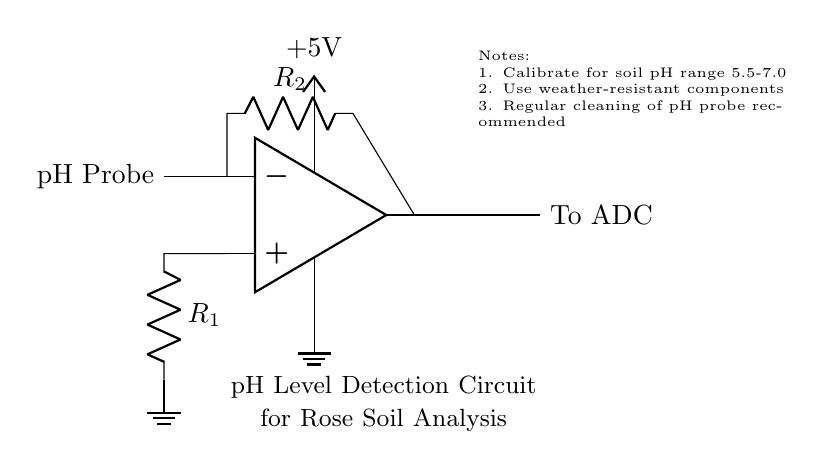What type of sensor is used in this circuit? The circuit uses a pH probe as indicated by the label on the left side of the op amplifier. This component detects the acidity or alkalinity of the soil.
Answer: pH probe What is the power supply voltage for the circuit? The circuit shows a +5V voltage connection to the operational amplifier, which powers the device.
Answer: 5V How many resistors are present in this circuit? The circuit diagram displays two resistors, labeled as R1 and R2, which are involved in the pH sensing process.
Answer: 2 What is the purpose of the op amp in this circuit? The operational amplifier is used to amplify the signal from the pH probe, making it suitable for the Analog-to-Digital Converter (ADC). This is crucial for proper soil analysis.
Answer: Amplification What is recommended for maintaining the pH probe? The notes included in the diagram specify that regular cleaning of the pH probe is recommended to ensure accurate readings and proper functioning.
Answer: Regular cleaning What is the output of the op amp connected to? The output of the operational amplifier is connected to an Analog-to-Digital Converter (ADC), which converts the amplified signal to a digital format for analysis.
Answer: To ADC What is the calibration range mentioned in the circuit? The notes indicate that the calibration should be done for the soil pH range of 5.5 to 7.0, which is important for measuring the soil's acidity.
Answer: 5.5-7.0 